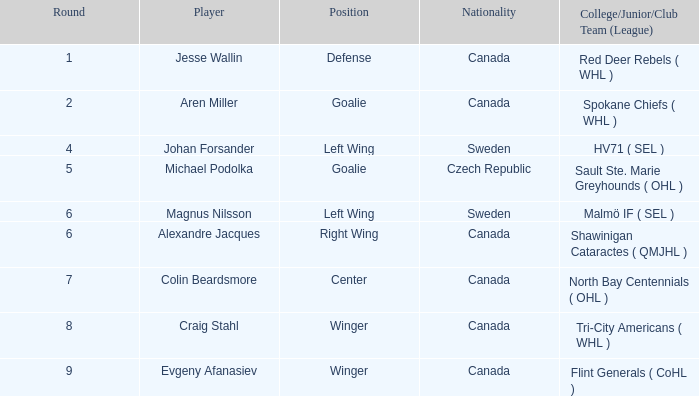What is the School/Junior/Club Group (Association) that has a Round bigger than 6, and a Place of winger, and a Player of evgeny afanasiev? Flint Generals ( CoHL ). 